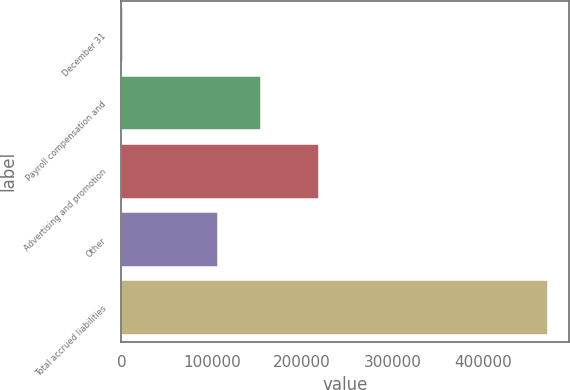Convert chart to OTSL. <chart><loc_0><loc_0><loc_500><loc_500><bar_chart><fcel>December 31<fcel>Payroll compensation and<fcel>Advertising and promotion<fcel>Other<fcel>Total accrued liabilities<nl><fcel>2004<fcel>154214<fcel>218376<fcel>107205<fcel>472096<nl></chart> 